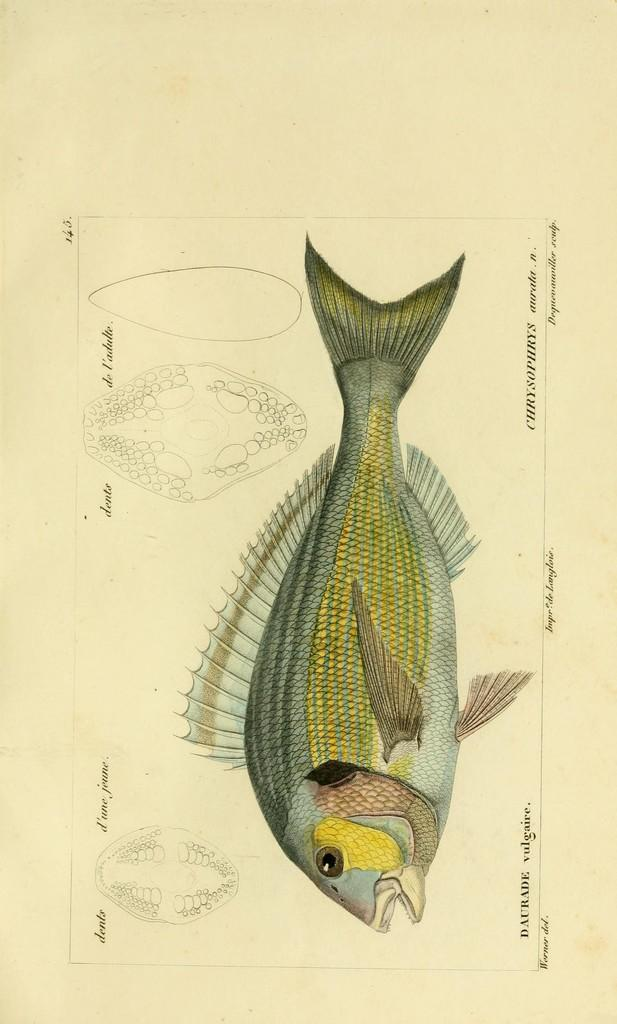What is the primary color of the paper in the image? The paper in the image is light brown in color. What is depicted on the paper? There is a diagram of a fish on the paper. How is the fish diagram presented? The fish diagram is colorful. What other elements can be seen in the image? There are sketches and words written in the image. How many stamps are attached to the fish diagram in the image? There are no stamps present in the image; it only features a colorful fish diagram, sketches, and words. Are there any spiders crawling on the paper in the image? There are no spiders visible in the image; it only contains a fish diagram, sketches, and words on a light brown paper. 